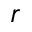Convert formula to latex. <formula><loc_0><loc_0><loc_500><loc_500>r</formula> 